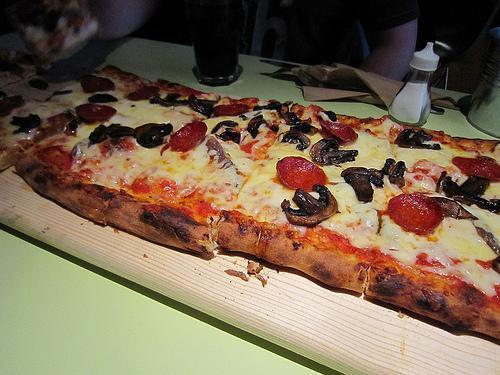How many pizzas?
Give a very brief answer. 1. 